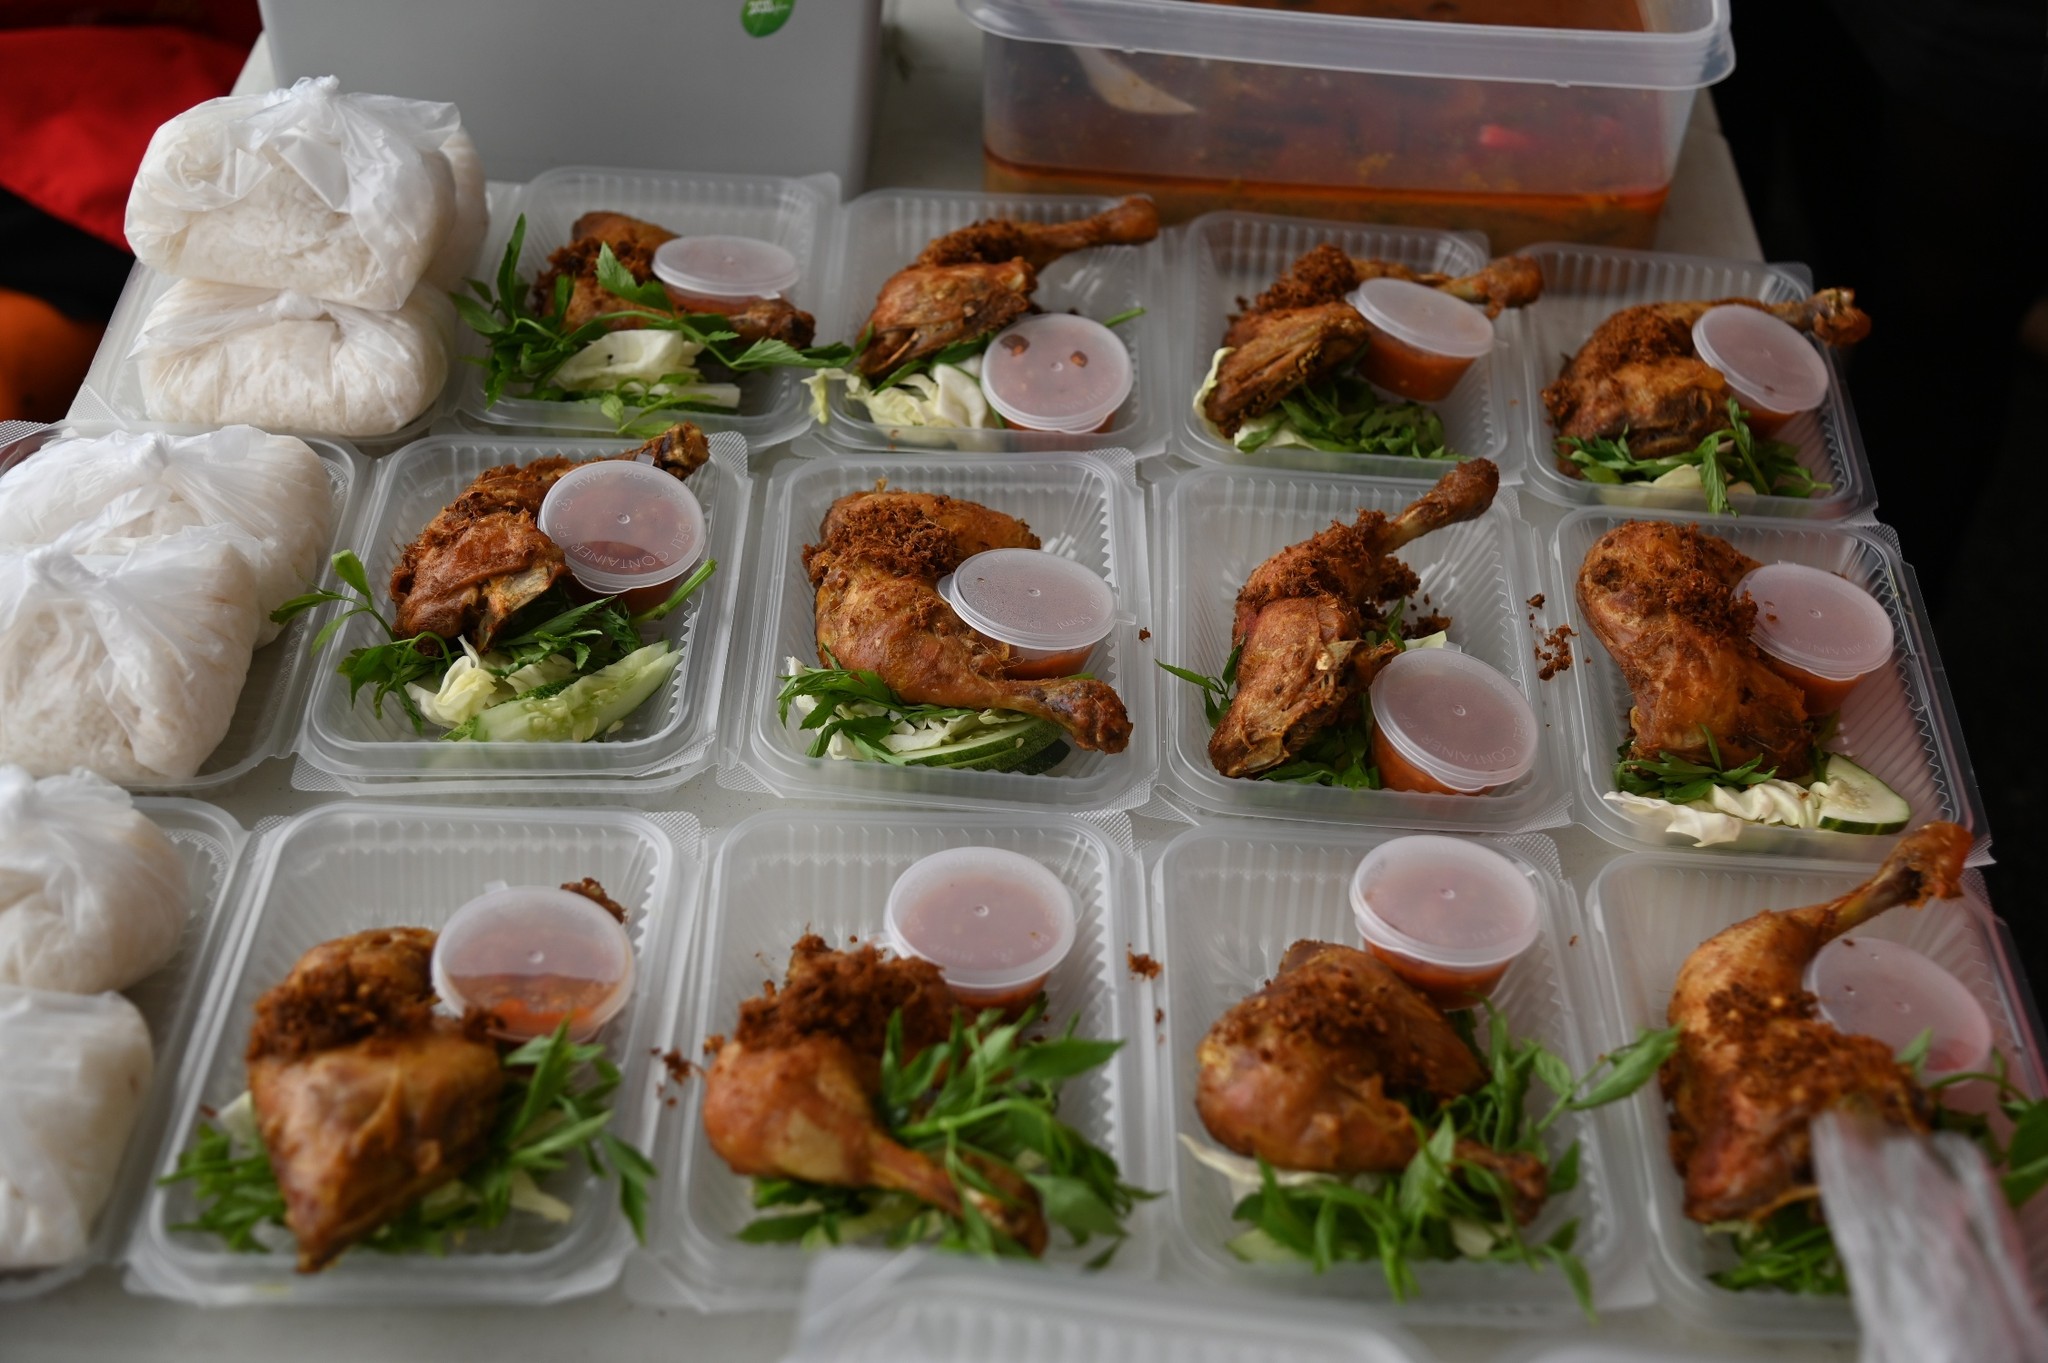What could be the possible event for which these meals are being prepared? Given the structured and uniform setup of the meals, along with the volume, it appears these are being prepared for a large event, possibly a community gathering, a corporate event, or a family reunion where catering needs are substantial. The choice of food suggests a casual yet satisfying menu often appreciated in large group settings. 